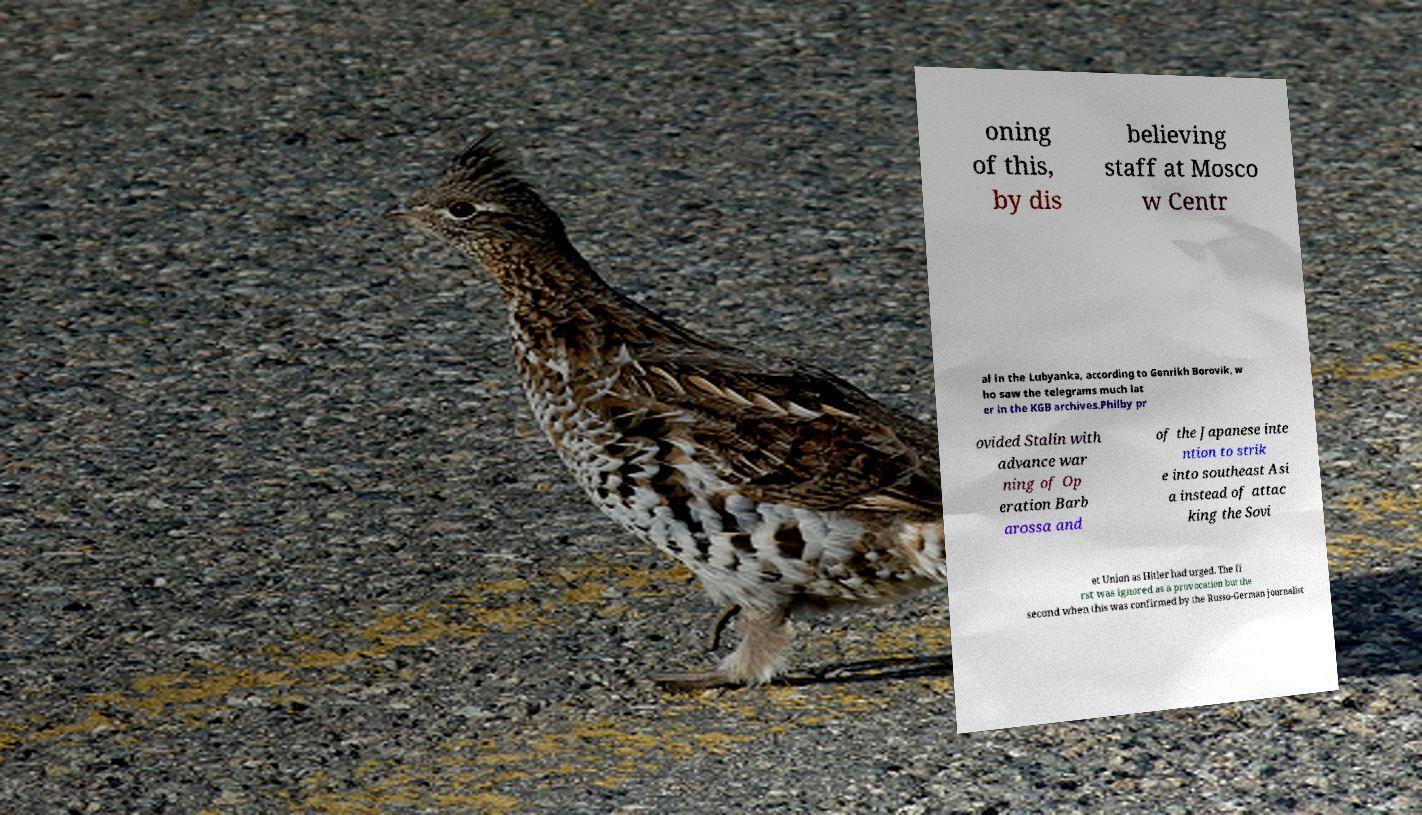What messages or text are displayed in this image? I need them in a readable, typed format. oning of this, by dis believing staff at Mosco w Centr al in the Lubyanka, according to Genrikh Borovik, w ho saw the telegrams much lat er in the KGB archives.Philby pr ovided Stalin with advance war ning of Op eration Barb arossa and of the Japanese inte ntion to strik e into southeast Asi a instead of attac king the Sovi et Union as Hitler had urged. The fi rst was ignored as a provocation but the second when this was confirmed by the Russo-German journalist 